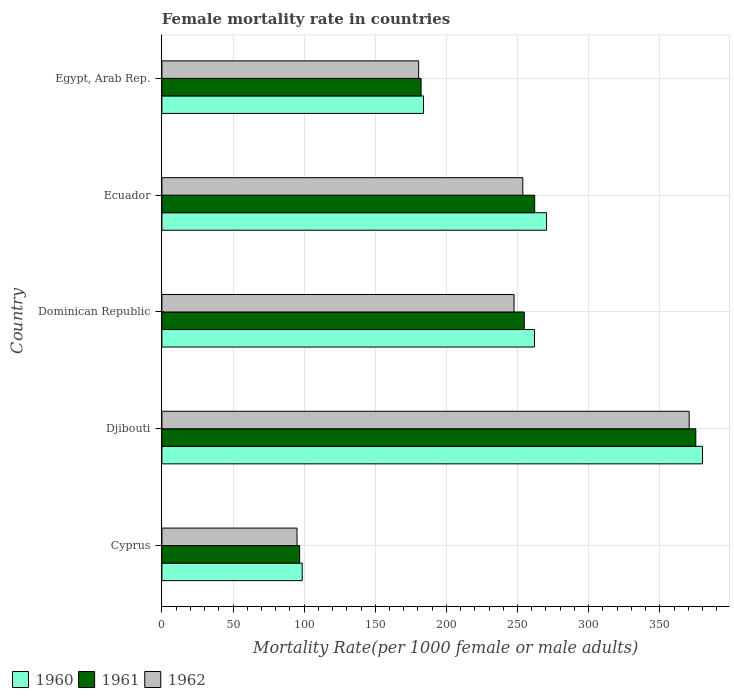How many different coloured bars are there?
Provide a short and direct response. 3. How many groups of bars are there?
Ensure brevity in your answer.  5. Are the number of bars per tick equal to the number of legend labels?
Offer a very short reply. Yes. Are the number of bars on each tick of the Y-axis equal?
Your answer should be compact. Yes. How many bars are there on the 3rd tick from the top?
Provide a short and direct response. 3. What is the label of the 2nd group of bars from the top?
Provide a succinct answer. Ecuador. What is the female mortality rate in 1960 in Cyprus?
Ensure brevity in your answer.  98.65. Across all countries, what is the maximum female mortality rate in 1962?
Provide a succinct answer. 370.66. Across all countries, what is the minimum female mortality rate in 1961?
Keep it short and to the point. 96.83. In which country was the female mortality rate in 1960 maximum?
Your answer should be very brief. Djibouti. In which country was the female mortality rate in 1961 minimum?
Your answer should be very brief. Cyprus. What is the total female mortality rate in 1960 in the graph?
Offer a terse response. 1194.87. What is the difference between the female mortality rate in 1960 in Cyprus and that in Ecuador?
Give a very brief answer. -171.74. What is the difference between the female mortality rate in 1961 in Cyprus and the female mortality rate in 1960 in Egypt, Arab Rep.?
Keep it short and to the point. -87.08. What is the average female mortality rate in 1961 per country?
Provide a succinct answer. 234.23. What is the difference between the female mortality rate in 1962 and female mortality rate in 1961 in Dominican Republic?
Give a very brief answer. -7.18. In how many countries, is the female mortality rate in 1961 greater than 370 ?
Offer a terse response. 1. What is the ratio of the female mortality rate in 1962 in Cyprus to that in Ecuador?
Ensure brevity in your answer.  0.37. Is the female mortality rate in 1960 in Dominican Republic less than that in Egypt, Arab Rep.?
Offer a terse response. No. Is the difference between the female mortality rate in 1962 in Djibouti and Egypt, Arab Rep. greater than the difference between the female mortality rate in 1961 in Djibouti and Egypt, Arab Rep.?
Your answer should be compact. No. What is the difference between the highest and the second highest female mortality rate in 1962?
Provide a succinct answer. 116.94. What is the difference between the highest and the lowest female mortality rate in 1962?
Provide a short and direct response. 275.66. In how many countries, is the female mortality rate in 1961 greater than the average female mortality rate in 1961 taken over all countries?
Keep it short and to the point. 3. Is the sum of the female mortality rate in 1962 in Cyprus and Dominican Republic greater than the maximum female mortality rate in 1960 across all countries?
Offer a very short reply. No. What does the 3rd bar from the top in Djibouti represents?
Ensure brevity in your answer.  1960. Is it the case that in every country, the sum of the female mortality rate in 1961 and female mortality rate in 1960 is greater than the female mortality rate in 1962?
Make the answer very short. Yes. How many bars are there?
Your answer should be compact. 15. What is the difference between two consecutive major ticks on the X-axis?
Offer a very short reply. 50. Are the values on the major ticks of X-axis written in scientific E-notation?
Give a very brief answer. No. Where does the legend appear in the graph?
Your answer should be compact. Bottom left. What is the title of the graph?
Your answer should be compact. Female mortality rate in countries. Does "1974" appear as one of the legend labels in the graph?
Your answer should be very brief. No. What is the label or title of the X-axis?
Provide a short and direct response. Mortality Rate(per 1000 female or male adults). What is the label or title of the Y-axis?
Your response must be concise. Country. What is the Mortality Rate(per 1000 female or male adults) of 1960 in Cyprus?
Provide a short and direct response. 98.65. What is the Mortality Rate(per 1000 female or male adults) of 1961 in Cyprus?
Give a very brief answer. 96.83. What is the Mortality Rate(per 1000 female or male adults) in 1962 in Cyprus?
Provide a short and direct response. 95. What is the Mortality Rate(per 1000 female or male adults) in 1960 in Djibouti?
Keep it short and to the point. 380. What is the Mortality Rate(per 1000 female or male adults) in 1961 in Djibouti?
Keep it short and to the point. 375.33. What is the Mortality Rate(per 1000 female or male adults) in 1962 in Djibouti?
Provide a short and direct response. 370.66. What is the Mortality Rate(per 1000 female or male adults) in 1960 in Dominican Republic?
Make the answer very short. 261.91. What is the Mortality Rate(per 1000 female or male adults) in 1961 in Dominican Republic?
Your answer should be compact. 254.73. What is the Mortality Rate(per 1000 female or male adults) in 1962 in Dominican Republic?
Offer a terse response. 247.55. What is the Mortality Rate(per 1000 female or male adults) in 1960 in Ecuador?
Provide a succinct answer. 270.39. What is the Mortality Rate(per 1000 female or male adults) of 1961 in Ecuador?
Provide a short and direct response. 262.05. What is the Mortality Rate(per 1000 female or male adults) in 1962 in Ecuador?
Your answer should be very brief. 253.71. What is the Mortality Rate(per 1000 female or male adults) in 1960 in Egypt, Arab Rep.?
Your answer should be very brief. 183.91. What is the Mortality Rate(per 1000 female or male adults) in 1961 in Egypt, Arab Rep.?
Your response must be concise. 182.2. What is the Mortality Rate(per 1000 female or male adults) of 1962 in Egypt, Arab Rep.?
Provide a succinct answer. 180.49. Across all countries, what is the maximum Mortality Rate(per 1000 female or male adults) in 1960?
Your response must be concise. 380. Across all countries, what is the maximum Mortality Rate(per 1000 female or male adults) of 1961?
Keep it short and to the point. 375.33. Across all countries, what is the maximum Mortality Rate(per 1000 female or male adults) of 1962?
Give a very brief answer. 370.66. Across all countries, what is the minimum Mortality Rate(per 1000 female or male adults) of 1960?
Your response must be concise. 98.65. Across all countries, what is the minimum Mortality Rate(per 1000 female or male adults) in 1961?
Your answer should be very brief. 96.83. Across all countries, what is the minimum Mortality Rate(per 1000 female or male adults) of 1962?
Provide a short and direct response. 95. What is the total Mortality Rate(per 1000 female or male adults) of 1960 in the graph?
Keep it short and to the point. 1194.87. What is the total Mortality Rate(per 1000 female or male adults) in 1961 in the graph?
Offer a very short reply. 1171.14. What is the total Mortality Rate(per 1000 female or male adults) of 1962 in the graph?
Keep it short and to the point. 1147.41. What is the difference between the Mortality Rate(per 1000 female or male adults) in 1960 in Cyprus and that in Djibouti?
Your answer should be very brief. -281.35. What is the difference between the Mortality Rate(per 1000 female or male adults) of 1961 in Cyprus and that in Djibouti?
Give a very brief answer. -278.5. What is the difference between the Mortality Rate(per 1000 female or male adults) of 1962 in Cyprus and that in Djibouti?
Offer a terse response. -275.65. What is the difference between the Mortality Rate(per 1000 female or male adults) of 1960 in Cyprus and that in Dominican Republic?
Ensure brevity in your answer.  -163.26. What is the difference between the Mortality Rate(per 1000 female or male adults) in 1961 in Cyprus and that in Dominican Republic?
Provide a succinct answer. -157.9. What is the difference between the Mortality Rate(per 1000 female or male adults) in 1962 in Cyprus and that in Dominican Republic?
Ensure brevity in your answer.  -152.54. What is the difference between the Mortality Rate(per 1000 female or male adults) of 1960 in Cyprus and that in Ecuador?
Give a very brief answer. -171.74. What is the difference between the Mortality Rate(per 1000 female or male adults) in 1961 in Cyprus and that in Ecuador?
Offer a terse response. -165.23. What is the difference between the Mortality Rate(per 1000 female or male adults) of 1962 in Cyprus and that in Ecuador?
Give a very brief answer. -158.71. What is the difference between the Mortality Rate(per 1000 female or male adults) of 1960 in Cyprus and that in Egypt, Arab Rep.?
Make the answer very short. -85.26. What is the difference between the Mortality Rate(per 1000 female or male adults) of 1961 in Cyprus and that in Egypt, Arab Rep.?
Your answer should be very brief. -85.37. What is the difference between the Mortality Rate(per 1000 female or male adults) of 1962 in Cyprus and that in Egypt, Arab Rep.?
Your answer should be very brief. -85.48. What is the difference between the Mortality Rate(per 1000 female or male adults) in 1960 in Djibouti and that in Dominican Republic?
Make the answer very short. 118.09. What is the difference between the Mortality Rate(per 1000 female or male adults) in 1961 in Djibouti and that in Dominican Republic?
Provide a succinct answer. 120.6. What is the difference between the Mortality Rate(per 1000 female or male adults) in 1962 in Djibouti and that in Dominican Republic?
Make the answer very short. 123.11. What is the difference between the Mortality Rate(per 1000 female or male adults) in 1960 in Djibouti and that in Ecuador?
Offer a very short reply. 109.61. What is the difference between the Mortality Rate(per 1000 female or male adults) of 1961 in Djibouti and that in Ecuador?
Offer a terse response. 113.28. What is the difference between the Mortality Rate(per 1000 female or male adults) in 1962 in Djibouti and that in Ecuador?
Provide a short and direct response. 116.94. What is the difference between the Mortality Rate(per 1000 female or male adults) of 1960 in Djibouti and that in Egypt, Arab Rep.?
Give a very brief answer. 196.09. What is the difference between the Mortality Rate(per 1000 female or male adults) in 1961 in Djibouti and that in Egypt, Arab Rep.?
Offer a terse response. 193.13. What is the difference between the Mortality Rate(per 1000 female or male adults) of 1962 in Djibouti and that in Egypt, Arab Rep.?
Your response must be concise. 190.17. What is the difference between the Mortality Rate(per 1000 female or male adults) in 1960 in Dominican Republic and that in Ecuador?
Your answer should be very brief. -8.48. What is the difference between the Mortality Rate(per 1000 female or male adults) in 1961 in Dominican Republic and that in Ecuador?
Keep it short and to the point. -7.33. What is the difference between the Mortality Rate(per 1000 female or male adults) in 1962 in Dominican Republic and that in Ecuador?
Offer a very short reply. -6.17. What is the difference between the Mortality Rate(per 1000 female or male adults) of 1960 in Dominican Republic and that in Egypt, Arab Rep.?
Offer a terse response. 78. What is the difference between the Mortality Rate(per 1000 female or male adults) of 1961 in Dominican Republic and that in Egypt, Arab Rep.?
Give a very brief answer. 72.53. What is the difference between the Mortality Rate(per 1000 female or male adults) in 1962 in Dominican Republic and that in Egypt, Arab Rep.?
Provide a succinct answer. 67.06. What is the difference between the Mortality Rate(per 1000 female or male adults) in 1960 in Ecuador and that in Egypt, Arab Rep.?
Your answer should be compact. 86.48. What is the difference between the Mortality Rate(per 1000 female or male adults) in 1961 in Ecuador and that in Egypt, Arab Rep.?
Your answer should be very brief. 79.86. What is the difference between the Mortality Rate(per 1000 female or male adults) in 1962 in Ecuador and that in Egypt, Arab Rep.?
Make the answer very short. 73.23. What is the difference between the Mortality Rate(per 1000 female or male adults) in 1960 in Cyprus and the Mortality Rate(per 1000 female or male adults) in 1961 in Djibouti?
Provide a succinct answer. -276.68. What is the difference between the Mortality Rate(per 1000 female or male adults) in 1960 in Cyprus and the Mortality Rate(per 1000 female or male adults) in 1962 in Djibouti?
Provide a short and direct response. -272. What is the difference between the Mortality Rate(per 1000 female or male adults) in 1961 in Cyprus and the Mortality Rate(per 1000 female or male adults) in 1962 in Djibouti?
Give a very brief answer. -273.83. What is the difference between the Mortality Rate(per 1000 female or male adults) in 1960 in Cyprus and the Mortality Rate(per 1000 female or male adults) in 1961 in Dominican Republic?
Make the answer very short. -156.07. What is the difference between the Mortality Rate(per 1000 female or male adults) in 1960 in Cyprus and the Mortality Rate(per 1000 female or male adults) in 1962 in Dominican Republic?
Your answer should be compact. -148.89. What is the difference between the Mortality Rate(per 1000 female or male adults) of 1961 in Cyprus and the Mortality Rate(per 1000 female or male adults) of 1962 in Dominican Republic?
Keep it short and to the point. -150.72. What is the difference between the Mortality Rate(per 1000 female or male adults) in 1960 in Cyprus and the Mortality Rate(per 1000 female or male adults) in 1961 in Ecuador?
Make the answer very short. -163.4. What is the difference between the Mortality Rate(per 1000 female or male adults) in 1960 in Cyprus and the Mortality Rate(per 1000 female or male adults) in 1962 in Ecuador?
Offer a very short reply. -155.06. What is the difference between the Mortality Rate(per 1000 female or male adults) of 1961 in Cyprus and the Mortality Rate(per 1000 female or male adults) of 1962 in Ecuador?
Give a very brief answer. -156.89. What is the difference between the Mortality Rate(per 1000 female or male adults) of 1960 in Cyprus and the Mortality Rate(per 1000 female or male adults) of 1961 in Egypt, Arab Rep.?
Ensure brevity in your answer.  -83.54. What is the difference between the Mortality Rate(per 1000 female or male adults) in 1960 in Cyprus and the Mortality Rate(per 1000 female or male adults) in 1962 in Egypt, Arab Rep.?
Ensure brevity in your answer.  -81.83. What is the difference between the Mortality Rate(per 1000 female or male adults) in 1961 in Cyprus and the Mortality Rate(per 1000 female or male adults) in 1962 in Egypt, Arab Rep.?
Make the answer very short. -83.66. What is the difference between the Mortality Rate(per 1000 female or male adults) in 1960 in Djibouti and the Mortality Rate(per 1000 female or male adults) in 1961 in Dominican Republic?
Give a very brief answer. 125.27. What is the difference between the Mortality Rate(per 1000 female or male adults) in 1960 in Djibouti and the Mortality Rate(per 1000 female or male adults) in 1962 in Dominican Republic?
Offer a terse response. 132.46. What is the difference between the Mortality Rate(per 1000 female or male adults) in 1961 in Djibouti and the Mortality Rate(per 1000 female or male adults) in 1962 in Dominican Republic?
Provide a short and direct response. 127.78. What is the difference between the Mortality Rate(per 1000 female or male adults) in 1960 in Djibouti and the Mortality Rate(per 1000 female or male adults) in 1961 in Ecuador?
Provide a short and direct response. 117.95. What is the difference between the Mortality Rate(per 1000 female or male adults) in 1960 in Djibouti and the Mortality Rate(per 1000 female or male adults) in 1962 in Ecuador?
Keep it short and to the point. 126.29. What is the difference between the Mortality Rate(per 1000 female or male adults) in 1961 in Djibouti and the Mortality Rate(per 1000 female or male adults) in 1962 in Ecuador?
Make the answer very short. 121.62. What is the difference between the Mortality Rate(per 1000 female or male adults) of 1960 in Djibouti and the Mortality Rate(per 1000 female or male adults) of 1961 in Egypt, Arab Rep.?
Provide a succinct answer. 197.81. What is the difference between the Mortality Rate(per 1000 female or male adults) in 1960 in Djibouti and the Mortality Rate(per 1000 female or male adults) in 1962 in Egypt, Arab Rep.?
Offer a very short reply. 199.52. What is the difference between the Mortality Rate(per 1000 female or male adults) in 1961 in Djibouti and the Mortality Rate(per 1000 female or male adults) in 1962 in Egypt, Arab Rep.?
Provide a short and direct response. 194.84. What is the difference between the Mortality Rate(per 1000 female or male adults) of 1960 in Dominican Republic and the Mortality Rate(per 1000 female or male adults) of 1961 in Ecuador?
Your response must be concise. -0.14. What is the difference between the Mortality Rate(per 1000 female or male adults) in 1960 in Dominican Republic and the Mortality Rate(per 1000 female or male adults) in 1962 in Ecuador?
Keep it short and to the point. 8.2. What is the difference between the Mortality Rate(per 1000 female or male adults) in 1960 in Dominican Republic and the Mortality Rate(per 1000 female or male adults) in 1961 in Egypt, Arab Rep.?
Keep it short and to the point. 79.71. What is the difference between the Mortality Rate(per 1000 female or male adults) of 1960 in Dominican Republic and the Mortality Rate(per 1000 female or male adults) of 1962 in Egypt, Arab Rep.?
Offer a very short reply. 81.42. What is the difference between the Mortality Rate(per 1000 female or male adults) of 1961 in Dominican Republic and the Mortality Rate(per 1000 female or male adults) of 1962 in Egypt, Arab Rep.?
Make the answer very short. 74.24. What is the difference between the Mortality Rate(per 1000 female or male adults) of 1960 in Ecuador and the Mortality Rate(per 1000 female or male adults) of 1961 in Egypt, Arab Rep.?
Provide a succinct answer. 88.2. What is the difference between the Mortality Rate(per 1000 female or male adults) of 1960 in Ecuador and the Mortality Rate(per 1000 female or male adults) of 1962 in Egypt, Arab Rep.?
Ensure brevity in your answer.  89.91. What is the difference between the Mortality Rate(per 1000 female or male adults) of 1961 in Ecuador and the Mortality Rate(per 1000 female or male adults) of 1962 in Egypt, Arab Rep.?
Offer a very short reply. 81.57. What is the average Mortality Rate(per 1000 female or male adults) in 1960 per country?
Provide a short and direct response. 238.97. What is the average Mortality Rate(per 1000 female or male adults) in 1961 per country?
Make the answer very short. 234.23. What is the average Mortality Rate(per 1000 female or male adults) of 1962 per country?
Offer a very short reply. 229.48. What is the difference between the Mortality Rate(per 1000 female or male adults) of 1960 and Mortality Rate(per 1000 female or male adults) of 1961 in Cyprus?
Keep it short and to the point. 1.82. What is the difference between the Mortality Rate(per 1000 female or male adults) in 1960 and Mortality Rate(per 1000 female or male adults) in 1962 in Cyprus?
Offer a very short reply. 3.65. What is the difference between the Mortality Rate(per 1000 female or male adults) of 1961 and Mortality Rate(per 1000 female or male adults) of 1962 in Cyprus?
Offer a very short reply. 1.82. What is the difference between the Mortality Rate(per 1000 female or male adults) of 1960 and Mortality Rate(per 1000 female or male adults) of 1961 in Djibouti?
Your answer should be compact. 4.67. What is the difference between the Mortality Rate(per 1000 female or male adults) in 1960 and Mortality Rate(per 1000 female or male adults) in 1962 in Djibouti?
Keep it short and to the point. 9.34. What is the difference between the Mortality Rate(per 1000 female or male adults) of 1961 and Mortality Rate(per 1000 female or male adults) of 1962 in Djibouti?
Keep it short and to the point. 4.67. What is the difference between the Mortality Rate(per 1000 female or male adults) in 1960 and Mortality Rate(per 1000 female or male adults) in 1961 in Dominican Republic?
Ensure brevity in your answer.  7.18. What is the difference between the Mortality Rate(per 1000 female or male adults) in 1960 and Mortality Rate(per 1000 female or male adults) in 1962 in Dominican Republic?
Make the answer very short. 14.36. What is the difference between the Mortality Rate(per 1000 female or male adults) of 1961 and Mortality Rate(per 1000 female or male adults) of 1962 in Dominican Republic?
Provide a succinct answer. 7.18. What is the difference between the Mortality Rate(per 1000 female or male adults) in 1960 and Mortality Rate(per 1000 female or male adults) in 1961 in Ecuador?
Keep it short and to the point. 8.34. What is the difference between the Mortality Rate(per 1000 female or male adults) in 1960 and Mortality Rate(per 1000 female or male adults) in 1962 in Ecuador?
Your response must be concise. 16.68. What is the difference between the Mortality Rate(per 1000 female or male adults) in 1961 and Mortality Rate(per 1000 female or male adults) in 1962 in Ecuador?
Give a very brief answer. 8.34. What is the difference between the Mortality Rate(per 1000 female or male adults) of 1960 and Mortality Rate(per 1000 female or male adults) of 1961 in Egypt, Arab Rep.?
Offer a terse response. 1.71. What is the difference between the Mortality Rate(per 1000 female or male adults) in 1960 and Mortality Rate(per 1000 female or male adults) in 1962 in Egypt, Arab Rep.?
Keep it short and to the point. 3.42. What is the difference between the Mortality Rate(per 1000 female or male adults) of 1961 and Mortality Rate(per 1000 female or male adults) of 1962 in Egypt, Arab Rep.?
Provide a short and direct response. 1.71. What is the ratio of the Mortality Rate(per 1000 female or male adults) of 1960 in Cyprus to that in Djibouti?
Your response must be concise. 0.26. What is the ratio of the Mortality Rate(per 1000 female or male adults) of 1961 in Cyprus to that in Djibouti?
Your answer should be compact. 0.26. What is the ratio of the Mortality Rate(per 1000 female or male adults) of 1962 in Cyprus to that in Djibouti?
Offer a terse response. 0.26. What is the ratio of the Mortality Rate(per 1000 female or male adults) of 1960 in Cyprus to that in Dominican Republic?
Ensure brevity in your answer.  0.38. What is the ratio of the Mortality Rate(per 1000 female or male adults) of 1961 in Cyprus to that in Dominican Republic?
Keep it short and to the point. 0.38. What is the ratio of the Mortality Rate(per 1000 female or male adults) in 1962 in Cyprus to that in Dominican Republic?
Offer a terse response. 0.38. What is the ratio of the Mortality Rate(per 1000 female or male adults) of 1960 in Cyprus to that in Ecuador?
Offer a very short reply. 0.36. What is the ratio of the Mortality Rate(per 1000 female or male adults) in 1961 in Cyprus to that in Ecuador?
Provide a succinct answer. 0.37. What is the ratio of the Mortality Rate(per 1000 female or male adults) of 1962 in Cyprus to that in Ecuador?
Ensure brevity in your answer.  0.37. What is the ratio of the Mortality Rate(per 1000 female or male adults) of 1960 in Cyprus to that in Egypt, Arab Rep.?
Your answer should be compact. 0.54. What is the ratio of the Mortality Rate(per 1000 female or male adults) in 1961 in Cyprus to that in Egypt, Arab Rep.?
Offer a very short reply. 0.53. What is the ratio of the Mortality Rate(per 1000 female or male adults) in 1962 in Cyprus to that in Egypt, Arab Rep.?
Your response must be concise. 0.53. What is the ratio of the Mortality Rate(per 1000 female or male adults) of 1960 in Djibouti to that in Dominican Republic?
Keep it short and to the point. 1.45. What is the ratio of the Mortality Rate(per 1000 female or male adults) of 1961 in Djibouti to that in Dominican Republic?
Offer a very short reply. 1.47. What is the ratio of the Mortality Rate(per 1000 female or male adults) of 1962 in Djibouti to that in Dominican Republic?
Provide a succinct answer. 1.5. What is the ratio of the Mortality Rate(per 1000 female or male adults) of 1960 in Djibouti to that in Ecuador?
Offer a terse response. 1.41. What is the ratio of the Mortality Rate(per 1000 female or male adults) of 1961 in Djibouti to that in Ecuador?
Make the answer very short. 1.43. What is the ratio of the Mortality Rate(per 1000 female or male adults) in 1962 in Djibouti to that in Ecuador?
Ensure brevity in your answer.  1.46. What is the ratio of the Mortality Rate(per 1000 female or male adults) of 1960 in Djibouti to that in Egypt, Arab Rep.?
Your answer should be compact. 2.07. What is the ratio of the Mortality Rate(per 1000 female or male adults) of 1961 in Djibouti to that in Egypt, Arab Rep.?
Your answer should be compact. 2.06. What is the ratio of the Mortality Rate(per 1000 female or male adults) of 1962 in Djibouti to that in Egypt, Arab Rep.?
Offer a terse response. 2.05. What is the ratio of the Mortality Rate(per 1000 female or male adults) of 1960 in Dominican Republic to that in Ecuador?
Your response must be concise. 0.97. What is the ratio of the Mortality Rate(per 1000 female or male adults) of 1961 in Dominican Republic to that in Ecuador?
Provide a succinct answer. 0.97. What is the ratio of the Mortality Rate(per 1000 female or male adults) in 1962 in Dominican Republic to that in Ecuador?
Ensure brevity in your answer.  0.98. What is the ratio of the Mortality Rate(per 1000 female or male adults) of 1960 in Dominican Republic to that in Egypt, Arab Rep.?
Offer a very short reply. 1.42. What is the ratio of the Mortality Rate(per 1000 female or male adults) in 1961 in Dominican Republic to that in Egypt, Arab Rep.?
Your response must be concise. 1.4. What is the ratio of the Mortality Rate(per 1000 female or male adults) of 1962 in Dominican Republic to that in Egypt, Arab Rep.?
Provide a succinct answer. 1.37. What is the ratio of the Mortality Rate(per 1000 female or male adults) in 1960 in Ecuador to that in Egypt, Arab Rep.?
Offer a very short reply. 1.47. What is the ratio of the Mortality Rate(per 1000 female or male adults) in 1961 in Ecuador to that in Egypt, Arab Rep.?
Your response must be concise. 1.44. What is the ratio of the Mortality Rate(per 1000 female or male adults) of 1962 in Ecuador to that in Egypt, Arab Rep.?
Provide a short and direct response. 1.41. What is the difference between the highest and the second highest Mortality Rate(per 1000 female or male adults) in 1960?
Offer a terse response. 109.61. What is the difference between the highest and the second highest Mortality Rate(per 1000 female or male adults) of 1961?
Your answer should be compact. 113.28. What is the difference between the highest and the second highest Mortality Rate(per 1000 female or male adults) in 1962?
Your response must be concise. 116.94. What is the difference between the highest and the lowest Mortality Rate(per 1000 female or male adults) in 1960?
Give a very brief answer. 281.35. What is the difference between the highest and the lowest Mortality Rate(per 1000 female or male adults) in 1961?
Your answer should be compact. 278.5. What is the difference between the highest and the lowest Mortality Rate(per 1000 female or male adults) in 1962?
Offer a terse response. 275.65. 